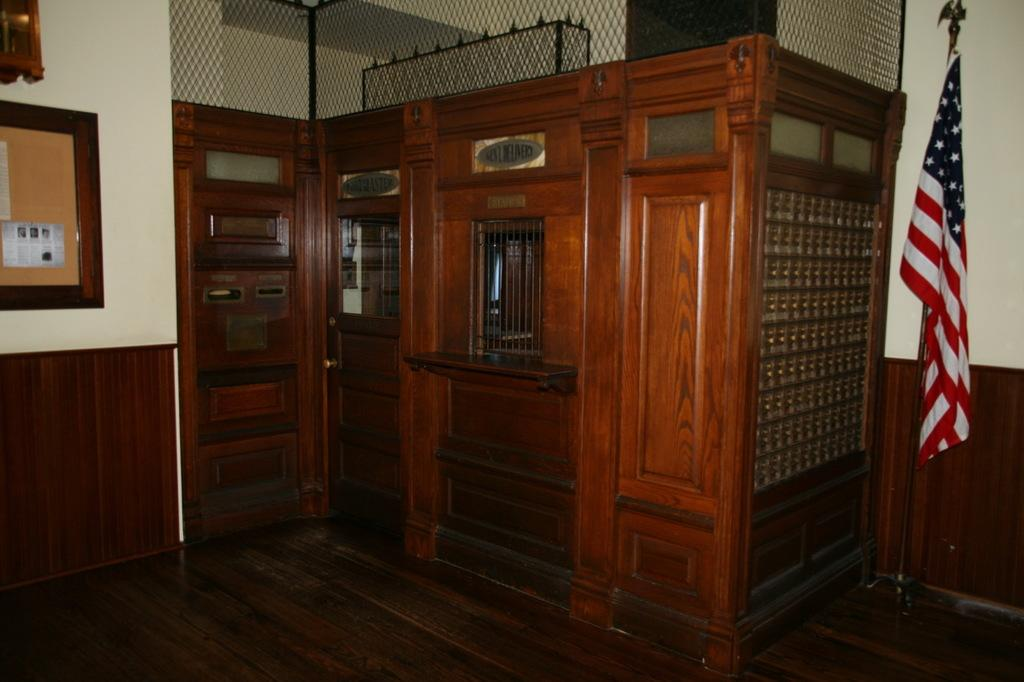What type of structure is located in the middle of the image? There is a wooden cabin in the middle of the image. What can be seen on the left side of the image? There is a frame on the wall on the left side of the image. What is present on the right side of the image? There is a flag on the right side of the image. What type of butter is being used to hold the frame on the wall in the image? There is no butter present in the image, and the frame is held in place by other means, not butter. 